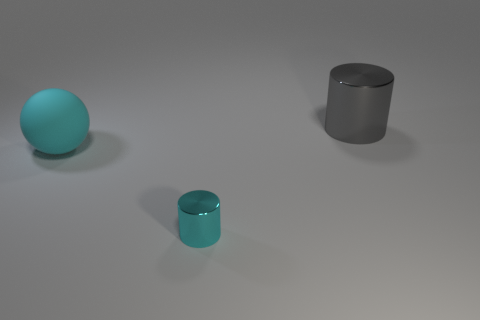Is there anything else that is the same size as the cyan shiny thing?
Offer a terse response. No. Are there any big cyan matte objects that have the same shape as the gray shiny thing?
Your response must be concise. No. The gray metal thing that is the same size as the cyan rubber thing is what shape?
Provide a succinct answer. Cylinder. What material is the cylinder behind the rubber thing left of the large thing that is on the right side of the cyan rubber object made of?
Your answer should be compact. Metal. Is the size of the cyan cylinder the same as the gray shiny cylinder?
Provide a succinct answer. No. What is the tiny cylinder made of?
Provide a succinct answer. Metal. What material is the big ball that is the same color as the tiny object?
Make the answer very short. Rubber. There is a large thing in front of the large gray metallic cylinder; is it the same shape as the small metal object?
Offer a terse response. No. How many things are either tiny things or gray cylinders?
Ensure brevity in your answer.  2. Is the cylinder on the left side of the gray cylinder made of the same material as the large cyan sphere?
Make the answer very short. No. 